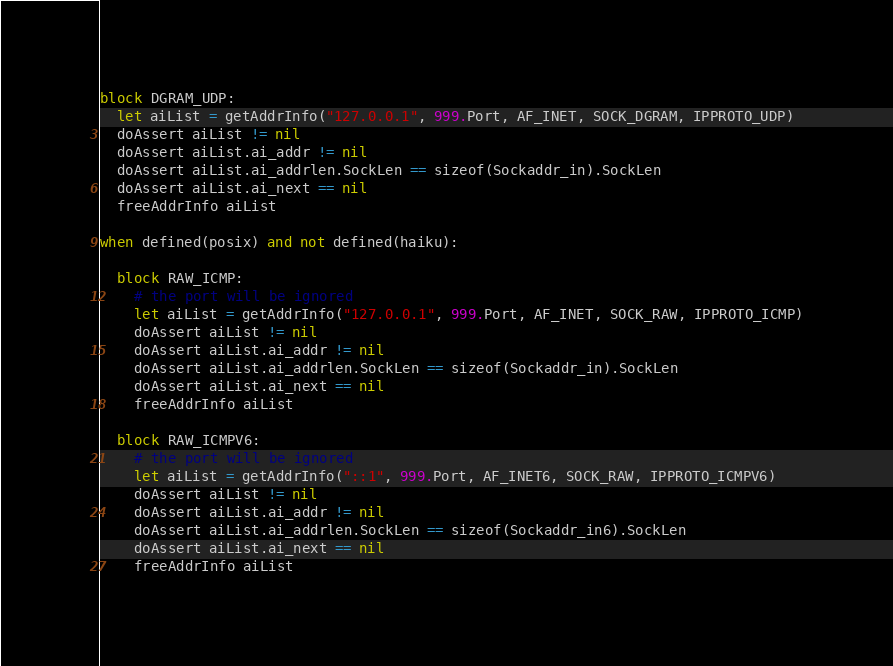<code> <loc_0><loc_0><loc_500><loc_500><_Nim_>
block DGRAM_UDP:
  let aiList = getAddrInfo("127.0.0.1", 999.Port, AF_INET, SOCK_DGRAM, IPPROTO_UDP)
  doAssert aiList != nil
  doAssert aiList.ai_addr != nil
  doAssert aiList.ai_addrlen.SockLen == sizeof(Sockaddr_in).SockLen
  doAssert aiList.ai_next == nil
  freeAddrInfo aiList

when defined(posix) and not defined(haiku):

  block RAW_ICMP:
    # the port will be ignored
    let aiList = getAddrInfo("127.0.0.1", 999.Port, AF_INET, SOCK_RAW, IPPROTO_ICMP)
    doAssert aiList != nil
    doAssert aiList.ai_addr != nil
    doAssert aiList.ai_addrlen.SockLen == sizeof(Sockaddr_in).SockLen
    doAssert aiList.ai_next == nil
    freeAddrInfo aiList

  block RAW_ICMPV6:
    # the port will be ignored
    let aiList = getAddrInfo("::1", 999.Port, AF_INET6, SOCK_RAW, IPPROTO_ICMPV6)
    doAssert aiList != nil
    doAssert aiList.ai_addr != nil
    doAssert aiList.ai_addrlen.SockLen == sizeof(Sockaddr_in6).SockLen
    doAssert aiList.ai_next == nil
    freeAddrInfo aiList
</code> 